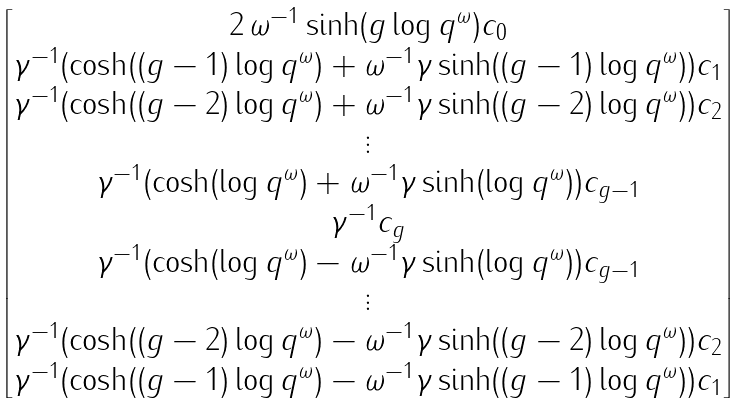<formula> <loc_0><loc_0><loc_500><loc_500>\begin{bmatrix} 2 \, \omega ^ { - 1 } \sinh ( g \log q ^ { \omega } ) c _ { 0 } \\ \gamma ^ { - 1 } ( \cosh ( ( g - 1 ) \log q ^ { \omega } ) + \omega ^ { - 1 } \gamma \sinh ( ( g - 1 ) \log q ^ { \omega } ) ) c _ { 1 } \\ \gamma ^ { - 1 } ( \cosh ( ( g - 2 ) \log q ^ { \omega } ) + \omega ^ { - 1 } \gamma \sinh ( ( g - 2 ) \log q ^ { \omega } ) ) c _ { 2 } \\ \vdots \\ \gamma ^ { - 1 } ( \cosh ( \log q ^ { \omega } ) + \omega ^ { - 1 } \gamma \sinh ( \log q ^ { \omega } ) ) c _ { g - 1 } \\ \gamma ^ { - 1 } c _ { g } \\ \gamma ^ { - 1 } ( \cosh ( \log q ^ { \omega } ) - \omega ^ { - 1 } \gamma \sinh ( \log q ^ { \omega } ) ) c _ { g - 1 } \\ \vdots \\ \gamma ^ { - 1 } ( \cosh ( ( g - 2 ) \log q ^ { \omega } ) - \omega ^ { - 1 } \gamma \sinh ( ( g - 2 ) \log q ^ { \omega } ) ) c _ { 2 } \\ \gamma ^ { - 1 } ( \cosh ( ( g - 1 ) \log q ^ { \omega } ) - \omega ^ { - 1 } \gamma \sinh ( ( g - 1 ) \log q ^ { \omega } ) ) c _ { 1 } \end{bmatrix}</formula> 